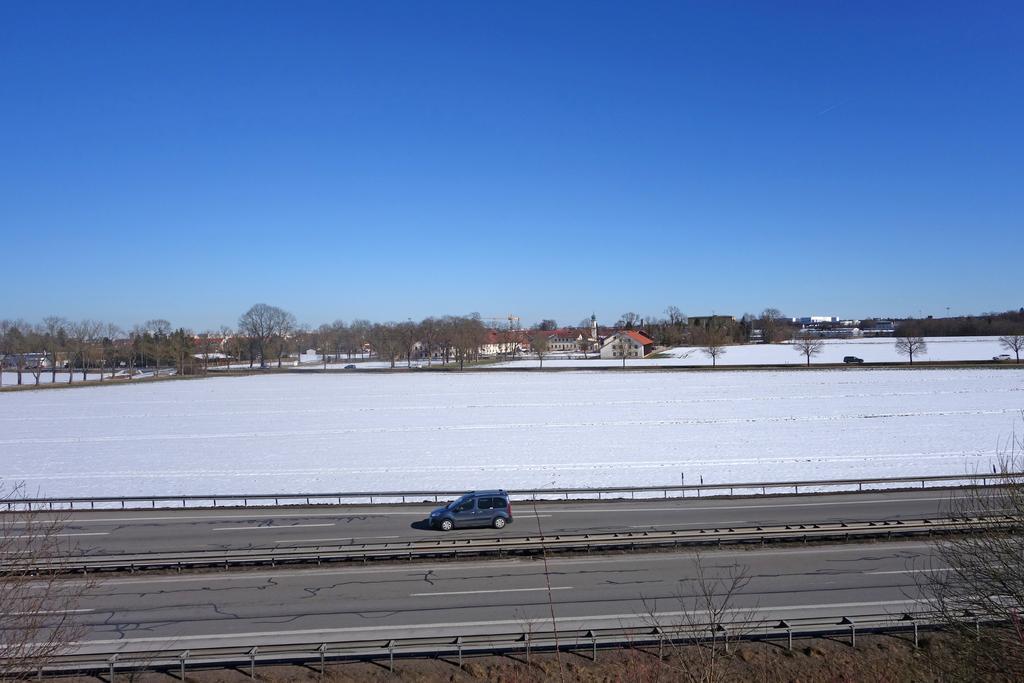How would you summarize this image in a sentence or two? In this image I can see a car which is in gray color. Background I can see the snow in white color, few houses in white color, trees in green color and the sky is in blue color. 